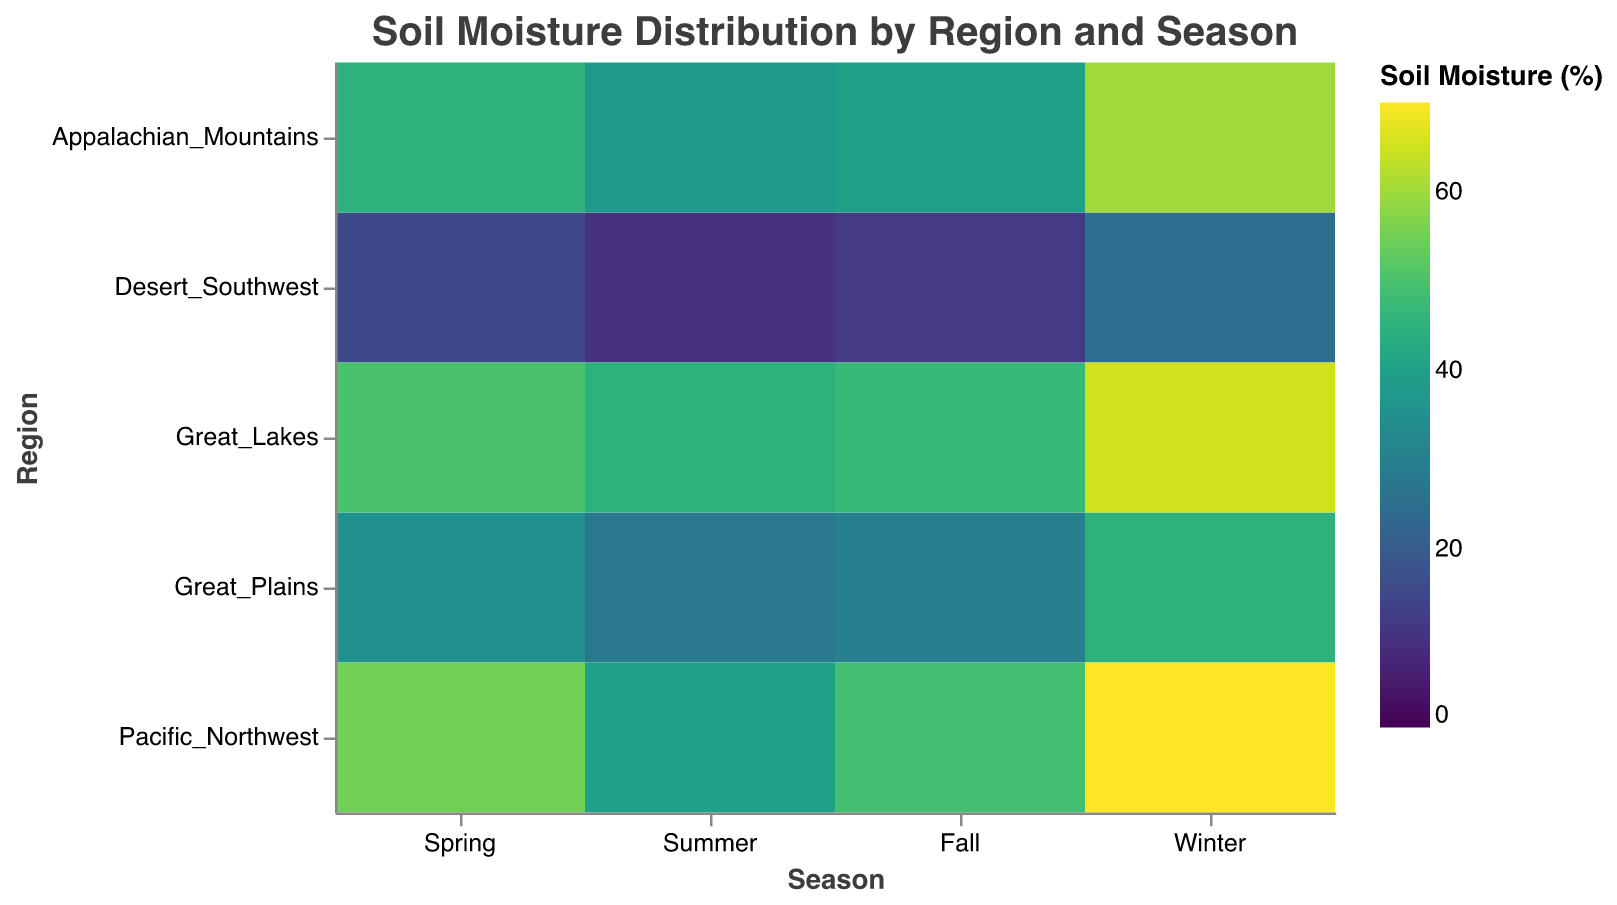What is the title of the heatmap? The heatmap's title is usually found at the top of the figure and provides an overview of what the heatmap represents.
Answer: Soil Moisture Distribution by Region and Season What does the color gradient represent in the heatmap? The legend in the figure specifies what the color gradient indicates. In this case, it represents the soil moisture percentage.
Answer: Soil Moisture (%) Which region has the highest soil moisture percentage in winter? Locate the winter column and identify the cell with the darkest color or highest value in that column. The highest value is in the Pacific Northwest region with a value of 70%.
Answer: Pacific Northwest What is the general trend of soil moisture in the Desert Southwest across the seasons? Examine the cells corresponding to the Desert Southwest across Spring, Summer, Fall, and Winter. The values are 15%, 10%, 12%, and 25%, respectively. It shows that the soil moisture remains low throughout the year, with a slight increase in winter.
Answer: Generally low, slight increase in Winter In which season does the Appalachian Mountains have the highest soil moisture percentage? Look at the cells corresponding to the Appalachian Mountains row and compare the values across all seasons. Winter has the highest value at 60%.
Answer: Winter Compare the soil moisture percentage of the Great Lakes region between Spring and Fall. Which season has higher moisture? Locate the cells for the Great Lakes in Spring (50%) and Fall (47%). Spring has a higher soil moisture percentage compared to Fall.
Answer: Spring What is the average soil moisture percentage for the Great Plains across all seasons? The values are 35 (Spring), 28 (Summer), 30 (Fall), and 45 (Winter). Add these values and divide by the number of seasons: (35+28+30+45)/4 = 34.5
Answer: 34.5 Which region shows the greatest variation in soil moisture percentage across seasons? Calculate the range for each region by subtracting the minimum value from the maximum value across the seasons. Pacific Northwest varies from 40% to 70%, which is a 30% difference, making it the greatest variation among regions.
Answer: Pacific Northwest Does any region have a consistent soil moisture percentage above 40% for all seasons? Check each region's seasonal values to see if they are all above 40%. The Great Lakes and Appalachian Mountains have values above 40% across all seasons.
Answer: Yes, Great Lakes and Appalachian Mountains What is the range of soil moisture percentages in the Great Plains region? Identify the highest and lowest values for the Great Plains. The values are 35%, 28%, 30%, and 45%, so the range is 45% - 28% = 17%.
Answer: 17% 